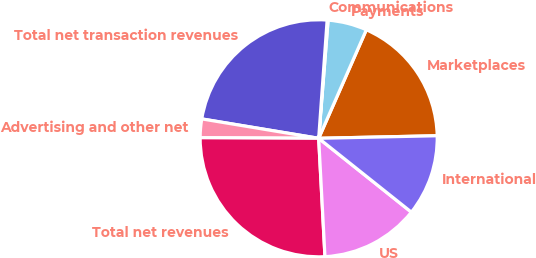Convert chart to OTSL. <chart><loc_0><loc_0><loc_500><loc_500><pie_chart><fcel>Marketplaces<fcel>Payments<fcel>Communications<fcel>Total net transaction revenues<fcel>Advertising and other net<fcel>Total net revenues<fcel>US<fcel>International<nl><fcel>18.07%<fcel>5.32%<fcel>0.13%<fcel>23.52%<fcel>2.54%<fcel>25.92%<fcel>13.45%<fcel>11.05%<nl></chart> 